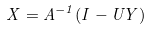<formula> <loc_0><loc_0><loc_500><loc_500>X = A ^ { - 1 } ( I - U Y )</formula> 